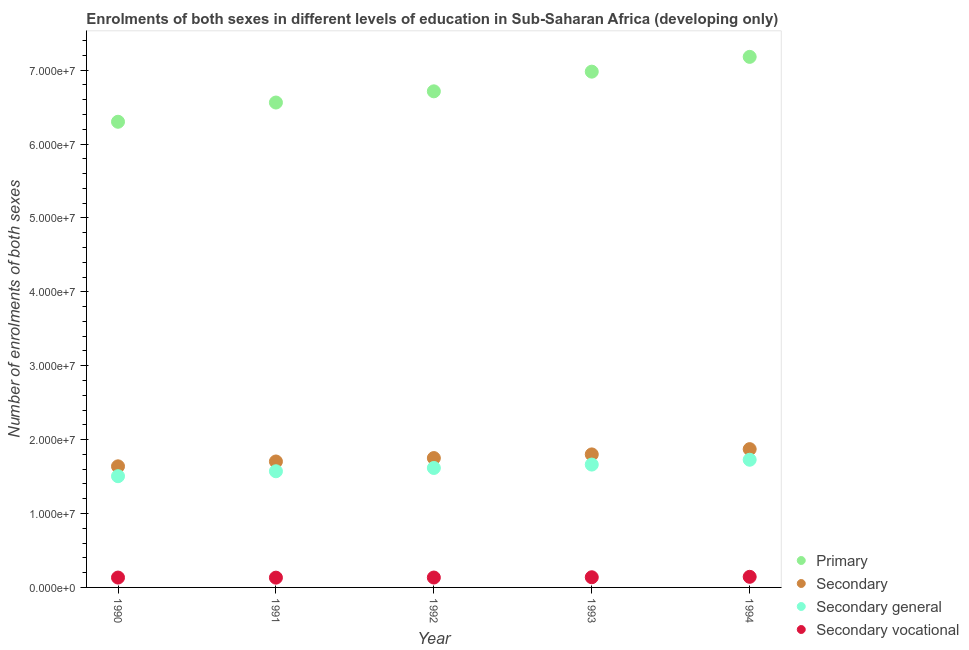How many different coloured dotlines are there?
Offer a terse response. 4. Is the number of dotlines equal to the number of legend labels?
Ensure brevity in your answer.  Yes. What is the number of enrolments in secondary education in 1992?
Make the answer very short. 1.75e+07. Across all years, what is the maximum number of enrolments in secondary vocational education?
Make the answer very short. 1.44e+06. Across all years, what is the minimum number of enrolments in secondary vocational education?
Offer a very short reply. 1.32e+06. In which year was the number of enrolments in secondary vocational education maximum?
Offer a terse response. 1994. What is the total number of enrolments in secondary vocational education in the graph?
Provide a short and direct response. 6.81e+06. What is the difference between the number of enrolments in secondary general education in 1991 and that in 1992?
Provide a succinct answer. -4.45e+05. What is the difference between the number of enrolments in secondary education in 1994 and the number of enrolments in secondary general education in 1990?
Ensure brevity in your answer.  3.66e+06. What is the average number of enrolments in secondary vocational education per year?
Ensure brevity in your answer.  1.36e+06. In the year 1993, what is the difference between the number of enrolments in secondary education and number of enrolments in secondary general education?
Make the answer very short. 1.38e+06. What is the ratio of the number of enrolments in primary education in 1990 to that in 1992?
Give a very brief answer. 0.94. Is the number of enrolments in primary education in 1992 less than that in 1994?
Keep it short and to the point. Yes. Is the difference between the number of enrolments in secondary education in 1990 and 1992 greater than the difference between the number of enrolments in secondary vocational education in 1990 and 1992?
Keep it short and to the point. No. What is the difference between the highest and the second highest number of enrolments in secondary education?
Offer a terse response. 7.13e+05. What is the difference between the highest and the lowest number of enrolments in secondary vocational education?
Make the answer very short. 1.13e+05. In how many years, is the number of enrolments in secondary vocational education greater than the average number of enrolments in secondary vocational education taken over all years?
Provide a succinct answer. 2. Is the sum of the number of enrolments in secondary vocational education in 1990 and 1991 greater than the maximum number of enrolments in primary education across all years?
Your answer should be very brief. No. Is it the case that in every year, the sum of the number of enrolments in secondary education and number of enrolments in primary education is greater than the sum of number of enrolments in secondary general education and number of enrolments in secondary vocational education?
Ensure brevity in your answer.  Yes. Does the number of enrolments in primary education monotonically increase over the years?
Provide a succinct answer. Yes. Is the number of enrolments in secondary education strictly greater than the number of enrolments in primary education over the years?
Your answer should be very brief. No. How many years are there in the graph?
Provide a succinct answer. 5. What is the difference between two consecutive major ticks on the Y-axis?
Your answer should be compact. 1.00e+07. Does the graph contain any zero values?
Your answer should be very brief. No. Does the graph contain grids?
Make the answer very short. No. What is the title of the graph?
Your answer should be very brief. Enrolments of both sexes in different levels of education in Sub-Saharan Africa (developing only). Does "Negligence towards children" appear as one of the legend labels in the graph?
Your response must be concise. No. What is the label or title of the Y-axis?
Ensure brevity in your answer.  Number of enrolments of both sexes. What is the Number of enrolments of both sexes in Primary in 1990?
Keep it short and to the point. 6.30e+07. What is the Number of enrolments of both sexes in Secondary in 1990?
Give a very brief answer. 1.64e+07. What is the Number of enrolments of both sexes in Secondary general in 1990?
Ensure brevity in your answer.  1.51e+07. What is the Number of enrolments of both sexes in Secondary vocational in 1990?
Your response must be concise. 1.34e+06. What is the Number of enrolments of both sexes in Primary in 1991?
Your answer should be very brief. 6.56e+07. What is the Number of enrolments of both sexes of Secondary in 1991?
Provide a succinct answer. 1.70e+07. What is the Number of enrolments of both sexes of Secondary general in 1991?
Give a very brief answer. 1.57e+07. What is the Number of enrolments of both sexes of Secondary vocational in 1991?
Give a very brief answer. 1.32e+06. What is the Number of enrolments of both sexes in Primary in 1992?
Provide a succinct answer. 6.71e+07. What is the Number of enrolments of both sexes in Secondary in 1992?
Your response must be concise. 1.75e+07. What is the Number of enrolments of both sexes in Secondary general in 1992?
Your answer should be very brief. 1.62e+07. What is the Number of enrolments of both sexes in Secondary vocational in 1992?
Your response must be concise. 1.34e+06. What is the Number of enrolments of both sexes of Primary in 1993?
Provide a succinct answer. 6.98e+07. What is the Number of enrolments of both sexes of Secondary in 1993?
Give a very brief answer. 1.80e+07. What is the Number of enrolments of both sexes in Secondary general in 1993?
Give a very brief answer. 1.66e+07. What is the Number of enrolments of both sexes in Secondary vocational in 1993?
Offer a terse response. 1.38e+06. What is the Number of enrolments of both sexes of Primary in 1994?
Offer a terse response. 7.18e+07. What is the Number of enrolments of both sexes of Secondary in 1994?
Offer a terse response. 1.87e+07. What is the Number of enrolments of both sexes of Secondary general in 1994?
Ensure brevity in your answer.  1.73e+07. What is the Number of enrolments of both sexes in Secondary vocational in 1994?
Provide a short and direct response. 1.44e+06. Across all years, what is the maximum Number of enrolments of both sexes in Primary?
Your answer should be compact. 7.18e+07. Across all years, what is the maximum Number of enrolments of both sexes of Secondary?
Provide a succinct answer. 1.87e+07. Across all years, what is the maximum Number of enrolments of both sexes of Secondary general?
Offer a terse response. 1.73e+07. Across all years, what is the maximum Number of enrolments of both sexes in Secondary vocational?
Provide a succinct answer. 1.44e+06. Across all years, what is the minimum Number of enrolments of both sexes of Primary?
Offer a terse response. 6.30e+07. Across all years, what is the minimum Number of enrolments of both sexes in Secondary?
Your response must be concise. 1.64e+07. Across all years, what is the minimum Number of enrolments of both sexes of Secondary general?
Give a very brief answer. 1.51e+07. Across all years, what is the minimum Number of enrolments of both sexes in Secondary vocational?
Your answer should be compact. 1.32e+06. What is the total Number of enrolments of both sexes of Primary in the graph?
Ensure brevity in your answer.  3.37e+08. What is the total Number of enrolments of both sexes of Secondary in the graph?
Provide a succinct answer. 8.76e+07. What is the total Number of enrolments of both sexes in Secondary general in the graph?
Provide a short and direct response. 8.08e+07. What is the total Number of enrolments of both sexes of Secondary vocational in the graph?
Make the answer very short. 6.81e+06. What is the difference between the Number of enrolments of both sexes in Primary in 1990 and that in 1991?
Offer a very short reply. -2.60e+06. What is the difference between the Number of enrolments of both sexes in Secondary in 1990 and that in 1991?
Provide a succinct answer. -6.55e+05. What is the difference between the Number of enrolments of both sexes of Secondary general in 1990 and that in 1991?
Your answer should be very brief. -6.68e+05. What is the difference between the Number of enrolments of both sexes of Secondary vocational in 1990 and that in 1991?
Give a very brief answer. 1.28e+04. What is the difference between the Number of enrolments of both sexes in Primary in 1990 and that in 1992?
Ensure brevity in your answer.  -4.12e+06. What is the difference between the Number of enrolments of both sexes of Secondary in 1990 and that in 1992?
Make the answer very short. -1.12e+06. What is the difference between the Number of enrolments of both sexes in Secondary general in 1990 and that in 1992?
Your answer should be compact. -1.11e+06. What is the difference between the Number of enrolments of both sexes of Secondary vocational in 1990 and that in 1992?
Your answer should be very brief. -2981.75. What is the difference between the Number of enrolments of both sexes of Primary in 1990 and that in 1993?
Keep it short and to the point. -6.78e+06. What is the difference between the Number of enrolments of both sexes in Secondary in 1990 and that in 1993?
Provide a succinct answer. -1.61e+06. What is the difference between the Number of enrolments of both sexes in Secondary general in 1990 and that in 1993?
Keep it short and to the point. -1.57e+06. What is the difference between the Number of enrolments of both sexes of Secondary vocational in 1990 and that in 1993?
Offer a very short reply. -4.10e+04. What is the difference between the Number of enrolments of both sexes in Primary in 1990 and that in 1994?
Your answer should be very brief. -8.78e+06. What is the difference between the Number of enrolments of both sexes of Secondary in 1990 and that in 1994?
Provide a short and direct response. -2.33e+06. What is the difference between the Number of enrolments of both sexes of Secondary general in 1990 and that in 1994?
Keep it short and to the point. -2.23e+06. What is the difference between the Number of enrolments of both sexes of Secondary vocational in 1990 and that in 1994?
Keep it short and to the point. -9.99e+04. What is the difference between the Number of enrolments of both sexes of Primary in 1991 and that in 1992?
Your answer should be very brief. -1.52e+06. What is the difference between the Number of enrolments of both sexes of Secondary in 1991 and that in 1992?
Your answer should be very brief. -4.61e+05. What is the difference between the Number of enrolments of both sexes of Secondary general in 1991 and that in 1992?
Your answer should be compact. -4.45e+05. What is the difference between the Number of enrolments of both sexes in Secondary vocational in 1991 and that in 1992?
Provide a short and direct response. -1.58e+04. What is the difference between the Number of enrolments of both sexes of Primary in 1991 and that in 1993?
Your answer should be compact. -4.18e+06. What is the difference between the Number of enrolments of both sexes in Secondary in 1991 and that in 1993?
Make the answer very short. -9.58e+05. What is the difference between the Number of enrolments of both sexes in Secondary general in 1991 and that in 1993?
Make the answer very short. -9.04e+05. What is the difference between the Number of enrolments of both sexes in Secondary vocational in 1991 and that in 1993?
Your answer should be compact. -5.38e+04. What is the difference between the Number of enrolments of both sexes in Primary in 1991 and that in 1994?
Your response must be concise. -6.18e+06. What is the difference between the Number of enrolments of both sexes of Secondary in 1991 and that in 1994?
Ensure brevity in your answer.  -1.67e+06. What is the difference between the Number of enrolments of both sexes in Secondary general in 1991 and that in 1994?
Your answer should be very brief. -1.56e+06. What is the difference between the Number of enrolments of both sexes in Secondary vocational in 1991 and that in 1994?
Give a very brief answer. -1.13e+05. What is the difference between the Number of enrolments of both sexes in Primary in 1992 and that in 1993?
Your response must be concise. -2.66e+06. What is the difference between the Number of enrolments of both sexes of Secondary in 1992 and that in 1993?
Keep it short and to the point. -4.97e+05. What is the difference between the Number of enrolments of both sexes in Secondary general in 1992 and that in 1993?
Offer a very short reply. -4.59e+05. What is the difference between the Number of enrolments of both sexes of Secondary vocational in 1992 and that in 1993?
Your answer should be very brief. -3.80e+04. What is the difference between the Number of enrolments of both sexes in Primary in 1992 and that in 1994?
Make the answer very short. -4.66e+06. What is the difference between the Number of enrolments of both sexes in Secondary in 1992 and that in 1994?
Give a very brief answer. -1.21e+06. What is the difference between the Number of enrolments of both sexes of Secondary general in 1992 and that in 1994?
Keep it short and to the point. -1.11e+06. What is the difference between the Number of enrolments of both sexes in Secondary vocational in 1992 and that in 1994?
Your answer should be very brief. -9.70e+04. What is the difference between the Number of enrolments of both sexes in Primary in 1993 and that in 1994?
Offer a terse response. -2.00e+06. What is the difference between the Number of enrolments of both sexes of Secondary in 1993 and that in 1994?
Give a very brief answer. -7.13e+05. What is the difference between the Number of enrolments of both sexes in Secondary general in 1993 and that in 1994?
Provide a succinct answer. -6.54e+05. What is the difference between the Number of enrolments of both sexes of Secondary vocational in 1993 and that in 1994?
Offer a very short reply. -5.89e+04. What is the difference between the Number of enrolments of both sexes of Primary in 1990 and the Number of enrolments of both sexes of Secondary in 1991?
Your answer should be compact. 4.60e+07. What is the difference between the Number of enrolments of both sexes of Primary in 1990 and the Number of enrolments of both sexes of Secondary general in 1991?
Keep it short and to the point. 4.73e+07. What is the difference between the Number of enrolments of both sexes of Primary in 1990 and the Number of enrolments of both sexes of Secondary vocational in 1991?
Ensure brevity in your answer.  6.17e+07. What is the difference between the Number of enrolments of both sexes in Secondary in 1990 and the Number of enrolments of both sexes in Secondary general in 1991?
Your answer should be very brief. 6.67e+05. What is the difference between the Number of enrolments of both sexes of Secondary in 1990 and the Number of enrolments of both sexes of Secondary vocational in 1991?
Provide a succinct answer. 1.51e+07. What is the difference between the Number of enrolments of both sexes of Secondary general in 1990 and the Number of enrolments of both sexes of Secondary vocational in 1991?
Provide a short and direct response. 1.37e+07. What is the difference between the Number of enrolments of both sexes of Primary in 1990 and the Number of enrolments of both sexes of Secondary in 1992?
Your response must be concise. 4.55e+07. What is the difference between the Number of enrolments of both sexes of Primary in 1990 and the Number of enrolments of both sexes of Secondary general in 1992?
Provide a succinct answer. 4.68e+07. What is the difference between the Number of enrolments of both sexes in Primary in 1990 and the Number of enrolments of both sexes in Secondary vocational in 1992?
Your response must be concise. 6.17e+07. What is the difference between the Number of enrolments of both sexes of Secondary in 1990 and the Number of enrolments of both sexes of Secondary general in 1992?
Offer a terse response. 2.22e+05. What is the difference between the Number of enrolments of both sexes of Secondary in 1990 and the Number of enrolments of both sexes of Secondary vocational in 1992?
Offer a very short reply. 1.50e+07. What is the difference between the Number of enrolments of both sexes in Secondary general in 1990 and the Number of enrolments of both sexes in Secondary vocational in 1992?
Give a very brief answer. 1.37e+07. What is the difference between the Number of enrolments of both sexes of Primary in 1990 and the Number of enrolments of both sexes of Secondary in 1993?
Provide a short and direct response. 4.50e+07. What is the difference between the Number of enrolments of both sexes in Primary in 1990 and the Number of enrolments of both sexes in Secondary general in 1993?
Give a very brief answer. 4.64e+07. What is the difference between the Number of enrolments of both sexes of Primary in 1990 and the Number of enrolments of both sexes of Secondary vocational in 1993?
Provide a short and direct response. 6.16e+07. What is the difference between the Number of enrolments of both sexes of Secondary in 1990 and the Number of enrolments of both sexes of Secondary general in 1993?
Your response must be concise. -2.37e+05. What is the difference between the Number of enrolments of both sexes in Secondary in 1990 and the Number of enrolments of both sexes in Secondary vocational in 1993?
Offer a very short reply. 1.50e+07. What is the difference between the Number of enrolments of both sexes of Secondary general in 1990 and the Number of enrolments of both sexes of Secondary vocational in 1993?
Offer a terse response. 1.37e+07. What is the difference between the Number of enrolments of both sexes of Primary in 1990 and the Number of enrolments of both sexes of Secondary in 1994?
Offer a very short reply. 4.43e+07. What is the difference between the Number of enrolments of both sexes of Primary in 1990 and the Number of enrolments of both sexes of Secondary general in 1994?
Keep it short and to the point. 4.57e+07. What is the difference between the Number of enrolments of both sexes of Primary in 1990 and the Number of enrolments of both sexes of Secondary vocational in 1994?
Your answer should be very brief. 6.16e+07. What is the difference between the Number of enrolments of both sexes of Secondary in 1990 and the Number of enrolments of both sexes of Secondary general in 1994?
Keep it short and to the point. -8.91e+05. What is the difference between the Number of enrolments of both sexes of Secondary in 1990 and the Number of enrolments of both sexes of Secondary vocational in 1994?
Your answer should be compact. 1.50e+07. What is the difference between the Number of enrolments of both sexes of Secondary general in 1990 and the Number of enrolments of both sexes of Secondary vocational in 1994?
Provide a succinct answer. 1.36e+07. What is the difference between the Number of enrolments of both sexes of Primary in 1991 and the Number of enrolments of both sexes of Secondary in 1992?
Ensure brevity in your answer.  4.81e+07. What is the difference between the Number of enrolments of both sexes of Primary in 1991 and the Number of enrolments of both sexes of Secondary general in 1992?
Provide a succinct answer. 4.94e+07. What is the difference between the Number of enrolments of both sexes of Primary in 1991 and the Number of enrolments of both sexes of Secondary vocational in 1992?
Your answer should be compact. 6.43e+07. What is the difference between the Number of enrolments of both sexes in Secondary in 1991 and the Number of enrolments of both sexes in Secondary general in 1992?
Your answer should be compact. 8.77e+05. What is the difference between the Number of enrolments of both sexes of Secondary in 1991 and the Number of enrolments of both sexes of Secondary vocational in 1992?
Provide a succinct answer. 1.57e+07. What is the difference between the Number of enrolments of both sexes in Secondary general in 1991 and the Number of enrolments of both sexes in Secondary vocational in 1992?
Offer a very short reply. 1.44e+07. What is the difference between the Number of enrolments of both sexes in Primary in 1991 and the Number of enrolments of both sexes in Secondary in 1993?
Your answer should be very brief. 4.76e+07. What is the difference between the Number of enrolments of both sexes in Primary in 1991 and the Number of enrolments of both sexes in Secondary general in 1993?
Your response must be concise. 4.90e+07. What is the difference between the Number of enrolments of both sexes of Primary in 1991 and the Number of enrolments of both sexes of Secondary vocational in 1993?
Give a very brief answer. 6.42e+07. What is the difference between the Number of enrolments of both sexes of Secondary in 1991 and the Number of enrolments of both sexes of Secondary general in 1993?
Your answer should be very brief. 4.18e+05. What is the difference between the Number of enrolments of both sexes of Secondary in 1991 and the Number of enrolments of both sexes of Secondary vocational in 1993?
Give a very brief answer. 1.57e+07. What is the difference between the Number of enrolments of both sexes in Secondary general in 1991 and the Number of enrolments of both sexes in Secondary vocational in 1993?
Offer a very short reply. 1.43e+07. What is the difference between the Number of enrolments of both sexes in Primary in 1991 and the Number of enrolments of both sexes in Secondary in 1994?
Provide a short and direct response. 4.69e+07. What is the difference between the Number of enrolments of both sexes in Primary in 1991 and the Number of enrolments of both sexes in Secondary general in 1994?
Your answer should be compact. 4.83e+07. What is the difference between the Number of enrolments of both sexes of Primary in 1991 and the Number of enrolments of both sexes of Secondary vocational in 1994?
Offer a terse response. 6.42e+07. What is the difference between the Number of enrolments of both sexes in Secondary in 1991 and the Number of enrolments of both sexes in Secondary general in 1994?
Provide a short and direct response. -2.36e+05. What is the difference between the Number of enrolments of both sexes in Secondary in 1991 and the Number of enrolments of both sexes in Secondary vocational in 1994?
Provide a succinct answer. 1.56e+07. What is the difference between the Number of enrolments of both sexes of Secondary general in 1991 and the Number of enrolments of both sexes of Secondary vocational in 1994?
Offer a very short reply. 1.43e+07. What is the difference between the Number of enrolments of both sexes in Primary in 1992 and the Number of enrolments of both sexes in Secondary in 1993?
Provide a succinct answer. 4.91e+07. What is the difference between the Number of enrolments of both sexes of Primary in 1992 and the Number of enrolments of both sexes of Secondary general in 1993?
Provide a short and direct response. 5.05e+07. What is the difference between the Number of enrolments of both sexes in Primary in 1992 and the Number of enrolments of both sexes in Secondary vocational in 1993?
Offer a very short reply. 6.58e+07. What is the difference between the Number of enrolments of both sexes in Secondary in 1992 and the Number of enrolments of both sexes in Secondary general in 1993?
Your answer should be compact. 8.80e+05. What is the difference between the Number of enrolments of both sexes of Secondary in 1992 and the Number of enrolments of both sexes of Secondary vocational in 1993?
Your response must be concise. 1.61e+07. What is the difference between the Number of enrolments of both sexes in Secondary general in 1992 and the Number of enrolments of both sexes in Secondary vocational in 1993?
Offer a terse response. 1.48e+07. What is the difference between the Number of enrolments of both sexes in Primary in 1992 and the Number of enrolments of both sexes in Secondary in 1994?
Provide a short and direct response. 4.84e+07. What is the difference between the Number of enrolments of both sexes of Primary in 1992 and the Number of enrolments of both sexes of Secondary general in 1994?
Give a very brief answer. 4.99e+07. What is the difference between the Number of enrolments of both sexes in Primary in 1992 and the Number of enrolments of both sexes in Secondary vocational in 1994?
Your answer should be compact. 6.57e+07. What is the difference between the Number of enrolments of both sexes in Secondary in 1992 and the Number of enrolments of both sexes in Secondary general in 1994?
Provide a short and direct response. 2.26e+05. What is the difference between the Number of enrolments of both sexes in Secondary in 1992 and the Number of enrolments of both sexes in Secondary vocational in 1994?
Offer a very short reply. 1.61e+07. What is the difference between the Number of enrolments of both sexes in Secondary general in 1992 and the Number of enrolments of both sexes in Secondary vocational in 1994?
Keep it short and to the point. 1.47e+07. What is the difference between the Number of enrolments of both sexes of Primary in 1993 and the Number of enrolments of both sexes of Secondary in 1994?
Offer a very short reply. 5.11e+07. What is the difference between the Number of enrolments of both sexes of Primary in 1993 and the Number of enrolments of both sexes of Secondary general in 1994?
Make the answer very short. 5.25e+07. What is the difference between the Number of enrolments of both sexes in Primary in 1993 and the Number of enrolments of both sexes in Secondary vocational in 1994?
Provide a short and direct response. 6.84e+07. What is the difference between the Number of enrolments of both sexes in Secondary in 1993 and the Number of enrolments of both sexes in Secondary general in 1994?
Your response must be concise. 7.23e+05. What is the difference between the Number of enrolments of both sexes in Secondary in 1993 and the Number of enrolments of both sexes in Secondary vocational in 1994?
Your answer should be very brief. 1.66e+07. What is the difference between the Number of enrolments of both sexes of Secondary general in 1993 and the Number of enrolments of both sexes of Secondary vocational in 1994?
Give a very brief answer. 1.52e+07. What is the average Number of enrolments of both sexes in Primary per year?
Provide a short and direct response. 6.75e+07. What is the average Number of enrolments of both sexes in Secondary per year?
Provide a short and direct response. 1.75e+07. What is the average Number of enrolments of both sexes of Secondary general per year?
Keep it short and to the point. 1.62e+07. What is the average Number of enrolments of both sexes of Secondary vocational per year?
Ensure brevity in your answer.  1.36e+06. In the year 1990, what is the difference between the Number of enrolments of both sexes of Primary and Number of enrolments of both sexes of Secondary?
Your answer should be compact. 4.66e+07. In the year 1990, what is the difference between the Number of enrolments of both sexes of Primary and Number of enrolments of both sexes of Secondary general?
Provide a short and direct response. 4.80e+07. In the year 1990, what is the difference between the Number of enrolments of both sexes of Primary and Number of enrolments of both sexes of Secondary vocational?
Offer a terse response. 6.17e+07. In the year 1990, what is the difference between the Number of enrolments of both sexes in Secondary and Number of enrolments of both sexes in Secondary general?
Provide a short and direct response. 1.34e+06. In the year 1990, what is the difference between the Number of enrolments of both sexes in Secondary and Number of enrolments of both sexes in Secondary vocational?
Ensure brevity in your answer.  1.51e+07. In the year 1990, what is the difference between the Number of enrolments of both sexes in Secondary general and Number of enrolments of both sexes in Secondary vocational?
Your answer should be very brief. 1.37e+07. In the year 1991, what is the difference between the Number of enrolments of both sexes in Primary and Number of enrolments of both sexes in Secondary?
Offer a terse response. 4.86e+07. In the year 1991, what is the difference between the Number of enrolments of both sexes of Primary and Number of enrolments of both sexes of Secondary general?
Give a very brief answer. 4.99e+07. In the year 1991, what is the difference between the Number of enrolments of both sexes in Primary and Number of enrolments of both sexes in Secondary vocational?
Make the answer very short. 6.43e+07. In the year 1991, what is the difference between the Number of enrolments of both sexes of Secondary and Number of enrolments of both sexes of Secondary general?
Provide a short and direct response. 1.32e+06. In the year 1991, what is the difference between the Number of enrolments of both sexes of Secondary and Number of enrolments of both sexes of Secondary vocational?
Provide a short and direct response. 1.57e+07. In the year 1991, what is the difference between the Number of enrolments of both sexes in Secondary general and Number of enrolments of both sexes in Secondary vocational?
Give a very brief answer. 1.44e+07. In the year 1992, what is the difference between the Number of enrolments of both sexes in Primary and Number of enrolments of both sexes in Secondary?
Your answer should be compact. 4.96e+07. In the year 1992, what is the difference between the Number of enrolments of both sexes in Primary and Number of enrolments of both sexes in Secondary general?
Give a very brief answer. 5.10e+07. In the year 1992, what is the difference between the Number of enrolments of both sexes in Primary and Number of enrolments of both sexes in Secondary vocational?
Your response must be concise. 6.58e+07. In the year 1992, what is the difference between the Number of enrolments of both sexes of Secondary and Number of enrolments of both sexes of Secondary general?
Ensure brevity in your answer.  1.34e+06. In the year 1992, what is the difference between the Number of enrolments of both sexes of Secondary and Number of enrolments of both sexes of Secondary vocational?
Your answer should be very brief. 1.62e+07. In the year 1992, what is the difference between the Number of enrolments of both sexes in Secondary general and Number of enrolments of both sexes in Secondary vocational?
Provide a succinct answer. 1.48e+07. In the year 1993, what is the difference between the Number of enrolments of both sexes in Primary and Number of enrolments of both sexes in Secondary?
Make the answer very short. 5.18e+07. In the year 1993, what is the difference between the Number of enrolments of both sexes of Primary and Number of enrolments of both sexes of Secondary general?
Make the answer very short. 5.32e+07. In the year 1993, what is the difference between the Number of enrolments of both sexes in Primary and Number of enrolments of both sexes in Secondary vocational?
Your answer should be very brief. 6.84e+07. In the year 1993, what is the difference between the Number of enrolments of both sexes of Secondary and Number of enrolments of both sexes of Secondary general?
Provide a short and direct response. 1.38e+06. In the year 1993, what is the difference between the Number of enrolments of both sexes in Secondary and Number of enrolments of both sexes in Secondary vocational?
Your answer should be compact. 1.66e+07. In the year 1993, what is the difference between the Number of enrolments of both sexes in Secondary general and Number of enrolments of both sexes in Secondary vocational?
Give a very brief answer. 1.52e+07. In the year 1994, what is the difference between the Number of enrolments of both sexes of Primary and Number of enrolments of both sexes of Secondary?
Give a very brief answer. 5.31e+07. In the year 1994, what is the difference between the Number of enrolments of both sexes of Primary and Number of enrolments of both sexes of Secondary general?
Make the answer very short. 5.45e+07. In the year 1994, what is the difference between the Number of enrolments of both sexes of Primary and Number of enrolments of both sexes of Secondary vocational?
Your answer should be compact. 7.04e+07. In the year 1994, what is the difference between the Number of enrolments of both sexes in Secondary and Number of enrolments of both sexes in Secondary general?
Offer a terse response. 1.44e+06. In the year 1994, what is the difference between the Number of enrolments of both sexes in Secondary and Number of enrolments of both sexes in Secondary vocational?
Offer a very short reply. 1.73e+07. In the year 1994, what is the difference between the Number of enrolments of both sexes of Secondary general and Number of enrolments of both sexes of Secondary vocational?
Provide a succinct answer. 1.58e+07. What is the ratio of the Number of enrolments of both sexes of Primary in 1990 to that in 1991?
Provide a short and direct response. 0.96. What is the ratio of the Number of enrolments of both sexes of Secondary in 1990 to that in 1991?
Make the answer very short. 0.96. What is the ratio of the Number of enrolments of both sexes in Secondary general in 1990 to that in 1991?
Ensure brevity in your answer.  0.96. What is the ratio of the Number of enrolments of both sexes in Secondary vocational in 1990 to that in 1991?
Provide a short and direct response. 1.01. What is the ratio of the Number of enrolments of both sexes of Primary in 1990 to that in 1992?
Keep it short and to the point. 0.94. What is the ratio of the Number of enrolments of both sexes in Secondary in 1990 to that in 1992?
Give a very brief answer. 0.94. What is the ratio of the Number of enrolments of both sexes in Secondary general in 1990 to that in 1992?
Offer a very short reply. 0.93. What is the ratio of the Number of enrolments of both sexes in Secondary vocational in 1990 to that in 1992?
Provide a succinct answer. 1. What is the ratio of the Number of enrolments of both sexes in Primary in 1990 to that in 1993?
Your response must be concise. 0.9. What is the ratio of the Number of enrolments of both sexes of Secondary in 1990 to that in 1993?
Provide a succinct answer. 0.91. What is the ratio of the Number of enrolments of both sexes of Secondary general in 1990 to that in 1993?
Your response must be concise. 0.91. What is the ratio of the Number of enrolments of both sexes of Secondary vocational in 1990 to that in 1993?
Provide a succinct answer. 0.97. What is the ratio of the Number of enrolments of both sexes in Primary in 1990 to that in 1994?
Make the answer very short. 0.88. What is the ratio of the Number of enrolments of both sexes in Secondary in 1990 to that in 1994?
Your answer should be compact. 0.88. What is the ratio of the Number of enrolments of both sexes in Secondary general in 1990 to that in 1994?
Your answer should be compact. 0.87. What is the ratio of the Number of enrolments of both sexes of Secondary vocational in 1990 to that in 1994?
Keep it short and to the point. 0.93. What is the ratio of the Number of enrolments of both sexes of Primary in 1991 to that in 1992?
Your answer should be compact. 0.98. What is the ratio of the Number of enrolments of both sexes in Secondary in 1991 to that in 1992?
Your answer should be compact. 0.97. What is the ratio of the Number of enrolments of both sexes of Secondary general in 1991 to that in 1992?
Make the answer very short. 0.97. What is the ratio of the Number of enrolments of both sexes of Secondary vocational in 1991 to that in 1992?
Your response must be concise. 0.99. What is the ratio of the Number of enrolments of both sexes of Primary in 1991 to that in 1993?
Offer a very short reply. 0.94. What is the ratio of the Number of enrolments of both sexes in Secondary in 1991 to that in 1993?
Your response must be concise. 0.95. What is the ratio of the Number of enrolments of both sexes in Secondary general in 1991 to that in 1993?
Provide a succinct answer. 0.95. What is the ratio of the Number of enrolments of both sexes of Secondary vocational in 1991 to that in 1993?
Ensure brevity in your answer.  0.96. What is the ratio of the Number of enrolments of both sexes in Primary in 1991 to that in 1994?
Offer a very short reply. 0.91. What is the ratio of the Number of enrolments of both sexes in Secondary in 1991 to that in 1994?
Offer a terse response. 0.91. What is the ratio of the Number of enrolments of both sexes in Secondary general in 1991 to that in 1994?
Provide a succinct answer. 0.91. What is the ratio of the Number of enrolments of both sexes in Secondary vocational in 1991 to that in 1994?
Make the answer very short. 0.92. What is the ratio of the Number of enrolments of both sexes of Primary in 1992 to that in 1993?
Give a very brief answer. 0.96. What is the ratio of the Number of enrolments of both sexes of Secondary in 1992 to that in 1993?
Provide a succinct answer. 0.97. What is the ratio of the Number of enrolments of both sexes of Secondary general in 1992 to that in 1993?
Ensure brevity in your answer.  0.97. What is the ratio of the Number of enrolments of both sexes of Secondary vocational in 1992 to that in 1993?
Keep it short and to the point. 0.97. What is the ratio of the Number of enrolments of both sexes in Primary in 1992 to that in 1994?
Make the answer very short. 0.94. What is the ratio of the Number of enrolments of both sexes of Secondary in 1992 to that in 1994?
Give a very brief answer. 0.94. What is the ratio of the Number of enrolments of both sexes of Secondary general in 1992 to that in 1994?
Provide a short and direct response. 0.94. What is the ratio of the Number of enrolments of both sexes of Secondary vocational in 1992 to that in 1994?
Your response must be concise. 0.93. What is the ratio of the Number of enrolments of both sexes of Primary in 1993 to that in 1994?
Your answer should be very brief. 0.97. What is the ratio of the Number of enrolments of both sexes in Secondary in 1993 to that in 1994?
Provide a short and direct response. 0.96. What is the ratio of the Number of enrolments of both sexes in Secondary general in 1993 to that in 1994?
Provide a succinct answer. 0.96. What is the ratio of the Number of enrolments of both sexes in Secondary vocational in 1993 to that in 1994?
Keep it short and to the point. 0.96. What is the difference between the highest and the second highest Number of enrolments of both sexes in Primary?
Give a very brief answer. 2.00e+06. What is the difference between the highest and the second highest Number of enrolments of both sexes of Secondary?
Provide a short and direct response. 7.13e+05. What is the difference between the highest and the second highest Number of enrolments of both sexes in Secondary general?
Your response must be concise. 6.54e+05. What is the difference between the highest and the second highest Number of enrolments of both sexes in Secondary vocational?
Provide a succinct answer. 5.89e+04. What is the difference between the highest and the lowest Number of enrolments of both sexes of Primary?
Offer a very short reply. 8.78e+06. What is the difference between the highest and the lowest Number of enrolments of both sexes in Secondary?
Provide a succinct answer. 2.33e+06. What is the difference between the highest and the lowest Number of enrolments of both sexes in Secondary general?
Your answer should be compact. 2.23e+06. What is the difference between the highest and the lowest Number of enrolments of both sexes of Secondary vocational?
Offer a terse response. 1.13e+05. 